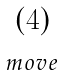<formula> <loc_0><loc_0><loc_500><loc_500>\begin{matrix} \left ( 4 \right ) \\ _ { m o v e } \end{matrix}</formula> 